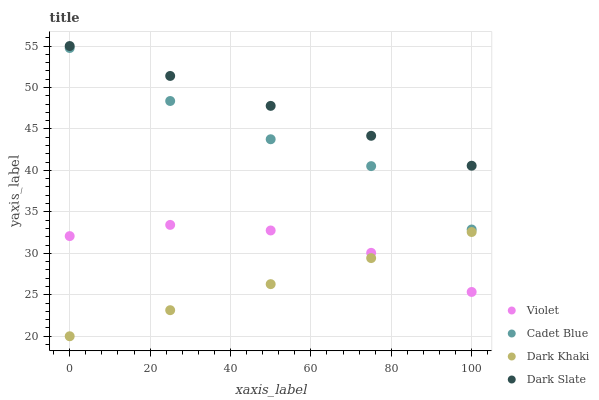Does Dark Khaki have the minimum area under the curve?
Answer yes or no. Yes. Does Dark Slate have the maximum area under the curve?
Answer yes or no. Yes. Does Cadet Blue have the minimum area under the curve?
Answer yes or no. No. Does Cadet Blue have the maximum area under the curve?
Answer yes or no. No. Is Dark Khaki the smoothest?
Answer yes or no. Yes. Is Cadet Blue the roughest?
Answer yes or no. Yes. Is Dark Slate the smoothest?
Answer yes or no. No. Is Dark Slate the roughest?
Answer yes or no. No. Does Dark Khaki have the lowest value?
Answer yes or no. Yes. Does Cadet Blue have the lowest value?
Answer yes or no. No. Does Dark Slate have the highest value?
Answer yes or no. Yes. Does Cadet Blue have the highest value?
Answer yes or no. No. Is Dark Khaki less than Cadet Blue?
Answer yes or no. Yes. Is Cadet Blue greater than Violet?
Answer yes or no. Yes. Does Dark Khaki intersect Violet?
Answer yes or no. Yes. Is Dark Khaki less than Violet?
Answer yes or no. No. Is Dark Khaki greater than Violet?
Answer yes or no. No. Does Dark Khaki intersect Cadet Blue?
Answer yes or no. No. 